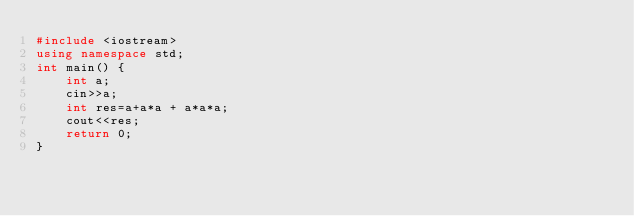Convert code to text. <code><loc_0><loc_0><loc_500><loc_500><_C++_>#include <iostream>
using namespace std;
int main() {
    int a;
    cin>>a;
    int res=a+a*a + a*a*a;
    cout<<res;
    return 0;
}
</code> 